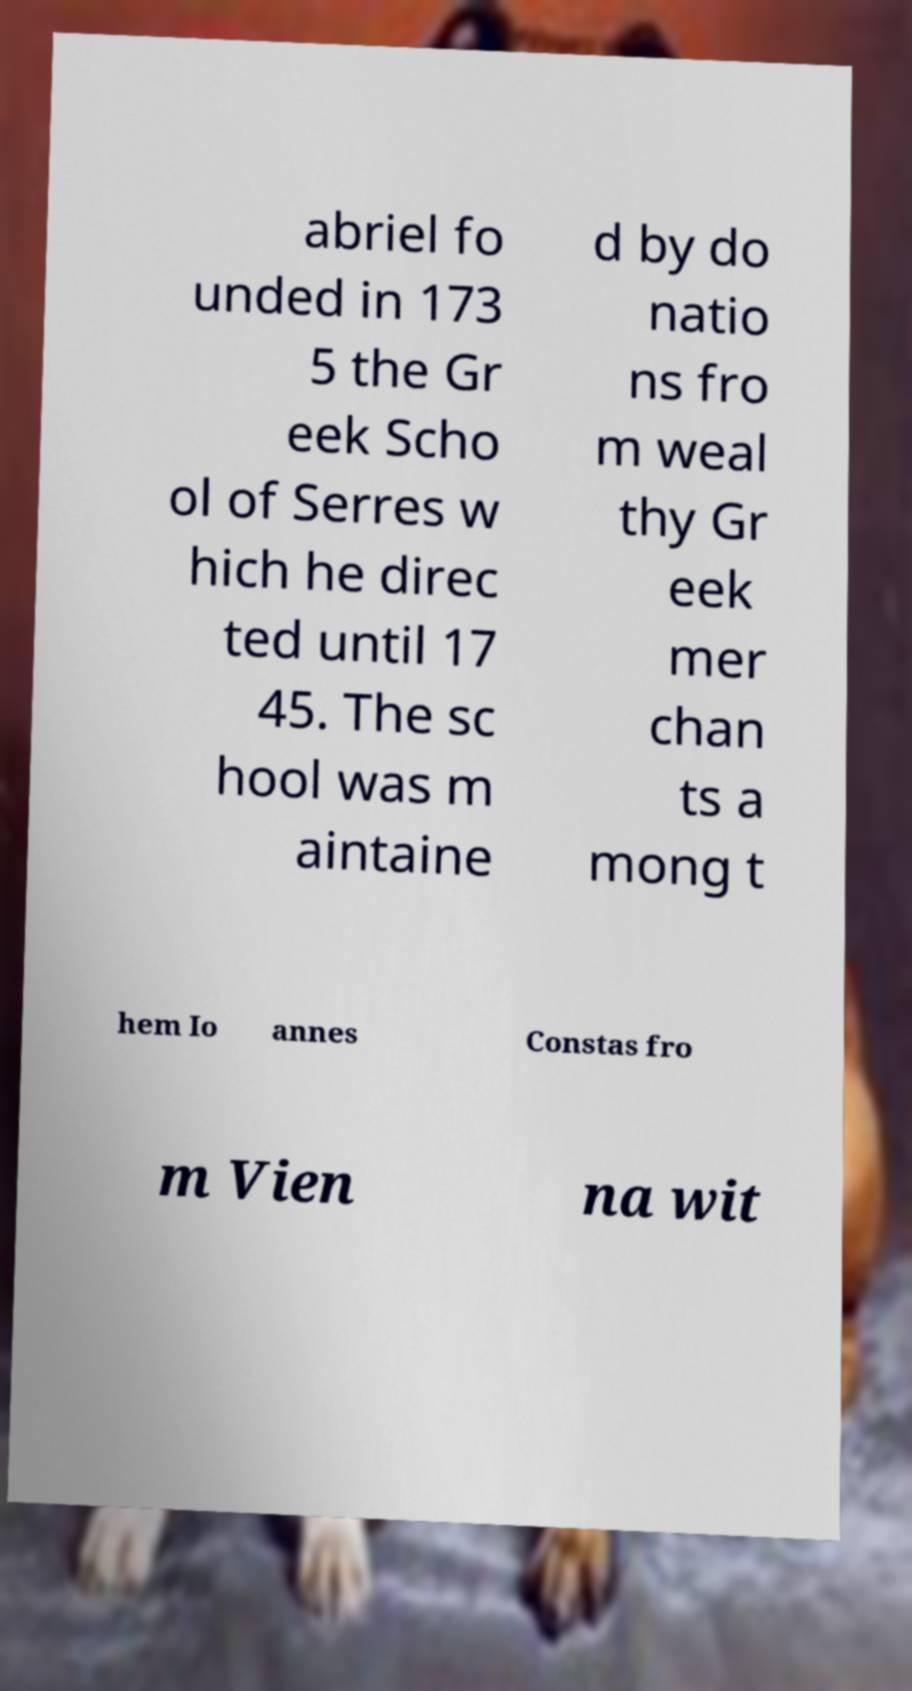Can you read and provide the text displayed in the image?This photo seems to have some interesting text. Can you extract and type it out for me? abriel fo unded in 173 5 the Gr eek Scho ol of Serres w hich he direc ted until 17 45. The sc hool was m aintaine d by do natio ns fro m weal thy Gr eek mer chan ts a mong t hem Io annes Constas fro m Vien na wit 